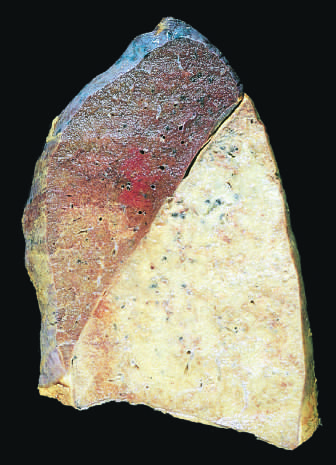what is uniformly consolidated?
Answer the question using a single word or phrase. The lower lobe 